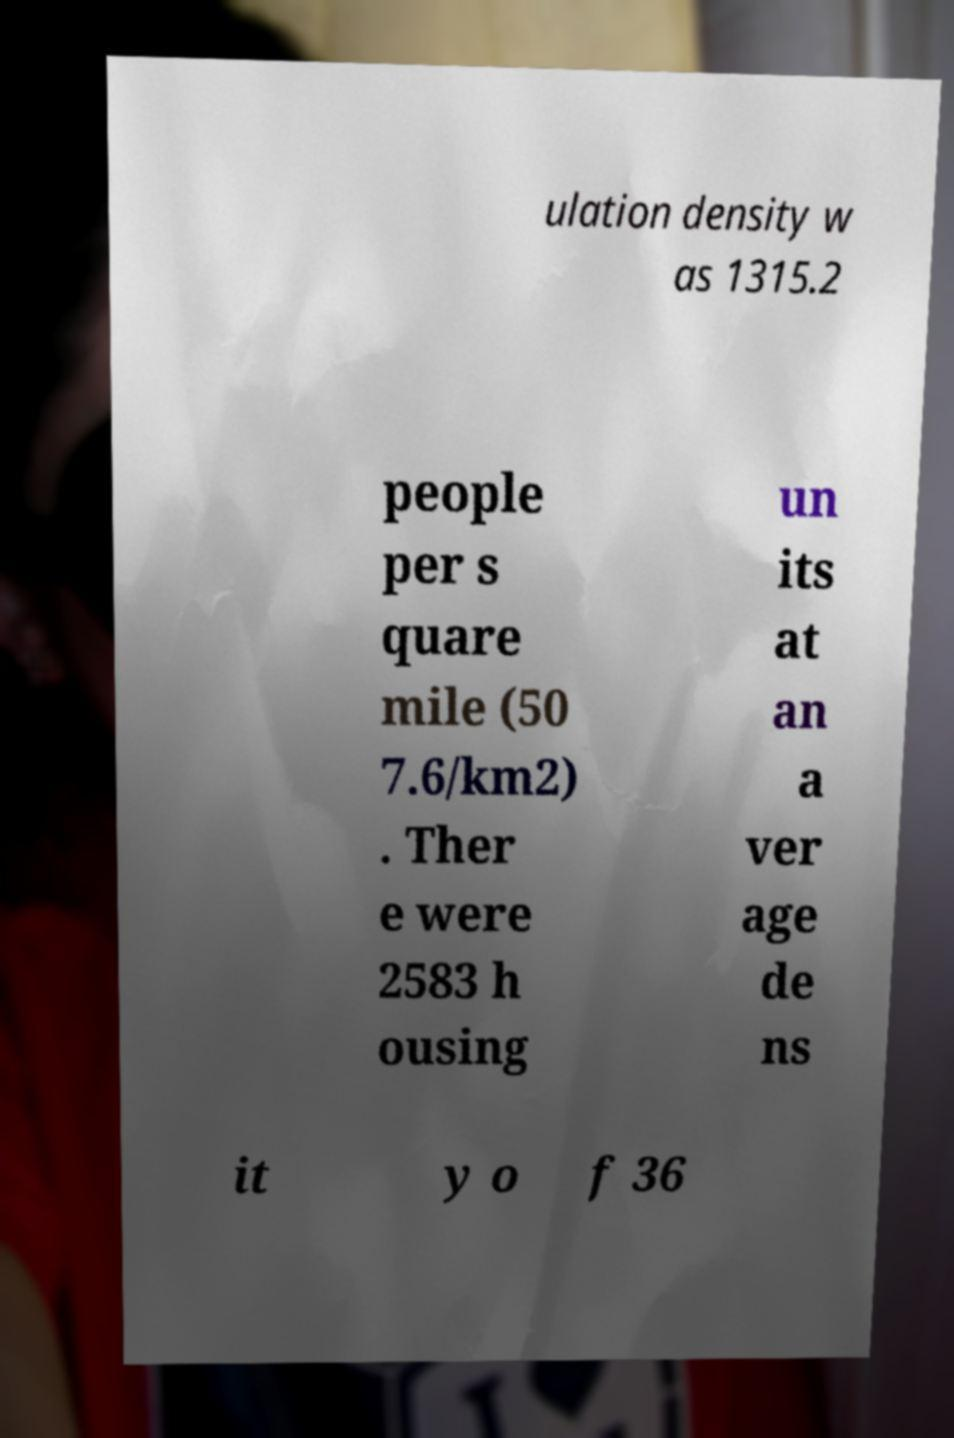Please identify and transcribe the text found in this image. ulation density w as 1315.2 people per s quare mile (50 7.6/km2) . Ther e were 2583 h ousing un its at an a ver age de ns it y o f 36 